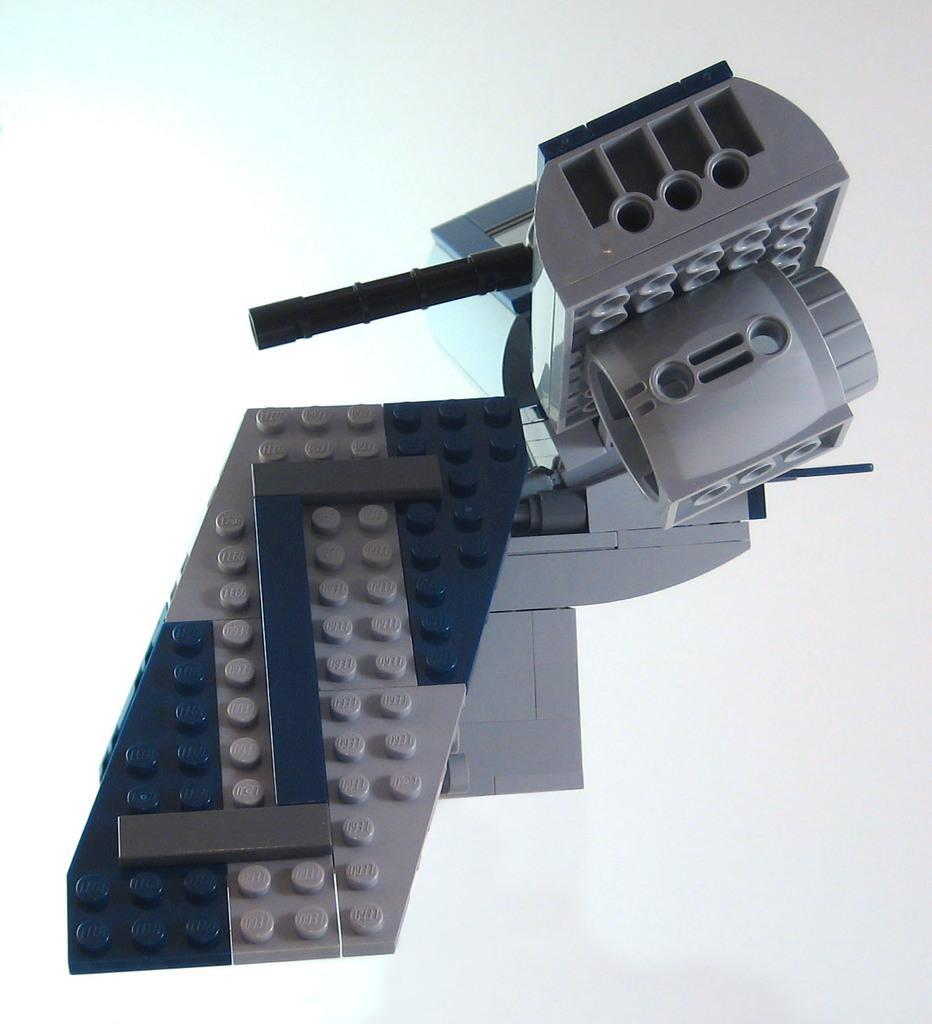Could you give a brief overview of what you see in this image? In this image we can see a grey and purple color toy. 